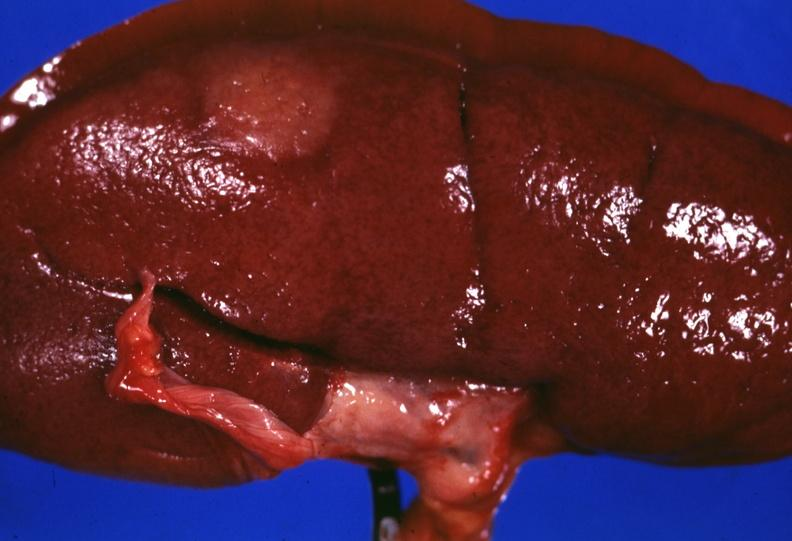s kidney present?
Answer the question using a single word or phrase. Yes 